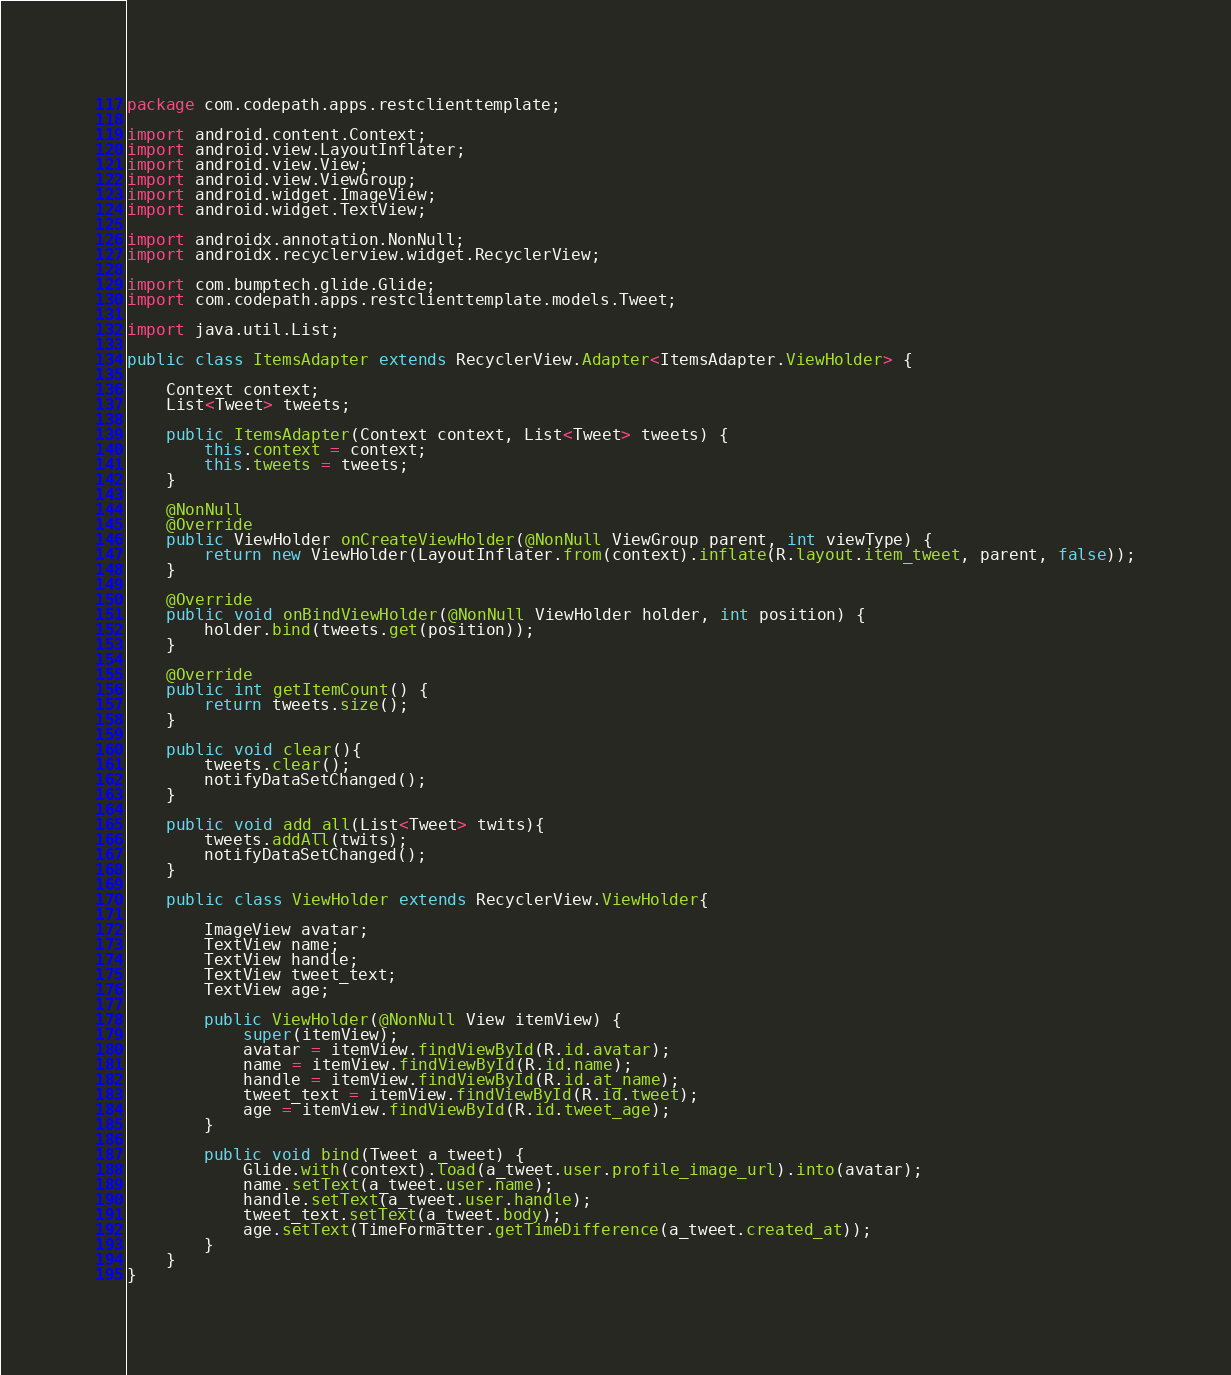Convert code to text. <code><loc_0><loc_0><loc_500><loc_500><_Java_>package com.codepath.apps.restclienttemplate;

import android.content.Context;
import android.view.LayoutInflater;
import android.view.View;
import android.view.ViewGroup;
import android.widget.ImageView;
import android.widget.TextView;

import androidx.annotation.NonNull;
import androidx.recyclerview.widget.RecyclerView;

import com.bumptech.glide.Glide;
import com.codepath.apps.restclienttemplate.models.Tweet;

import java.util.List;

public class ItemsAdapter extends RecyclerView.Adapter<ItemsAdapter.ViewHolder> {

    Context context;
    List<Tweet> tweets;

    public ItemsAdapter(Context context, List<Tweet> tweets) {
        this.context = context;
        this.tweets = tweets;
    }

    @NonNull
    @Override
    public ViewHolder onCreateViewHolder(@NonNull ViewGroup parent, int viewType) {
        return new ViewHolder(LayoutInflater.from(context).inflate(R.layout.item_tweet, parent, false));
    }

    @Override
    public void onBindViewHolder(@NonNull ViewHolder holder, int position) {
        holder.bind(tweets.get(position));
    }

    @Override
    public int getItemCount() {
        return tweets.size();
    }

    public void clear(){
        tweets.clear();
        notifyDataSetChanged();
    }

    public void add_all(List<Tweet> twits){
        tweets.addAll(twits);
        notifyDataSetChanged();
    }

    public class ViewHolder extends RecyclerView.ViewHolder{

        ImageView avatar;
        TextView name;
        TextView handle;
        TextView tweet_text;
        TextView age;

        public ViewHolder(@NonNull View itemView) {
            super(itemView);
            avatar = itemView.findViewById(R.id.avatar);
            name = itemView.findViewById(R.id.name);
            handle = itemView.findViewById(R.id.at_name);
            tweet_text = itemView.findViewById(R.id.tweet);
            age = itemView.findViewById(R.id.tweet_age);
        }

        public void bind(Tweet a_tweet) {
            Glide.with(context).load(a_tweet.user.profile_image_url).into(avatar);
            name.setText(a_tweet.user.name);
            handle.setText(a_tweet.user.handle);
            tweet_text.setText(a_tweet.body);
            age.setText(TimeFormatter.getTimeDifference(a_tweet.created_at));
        }
    }
}</code> 